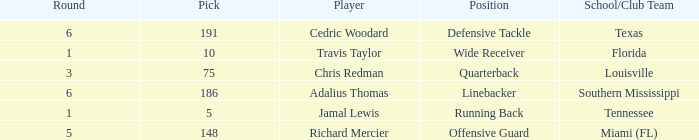Where's the first round that southern mississippi shows up during the draft? 6.0. 